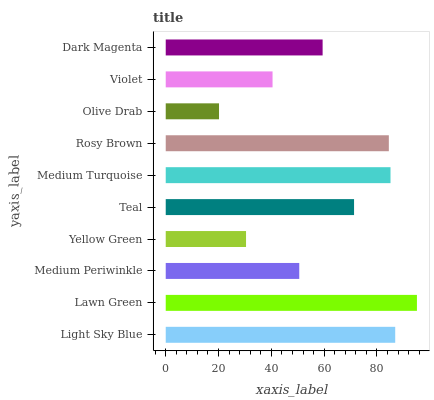Is Olive Drab the minimum?
Answer yes or no. Yes. Is Lawn Green the maximum?
Answer yes or no. Yes. Is Medium Periwinkle the minimum?
Answer yes or no. No. Is Medium Periwinkle the maximum?
Answer yes or no. No. Is Lawn Green greater than Medium Periwinkle?
Answer yes or no. Yes. Is Medium Periwinkle less than Lawn Green?
Answer yes or no. Yes. Is Medium Periwinkle greater than Lawn Green?
Answer yes or no. No. Is Lawn Green less than Medium Periwinkle?
Answer yes or no. No. Is Teal the high median?
Answer yes or no. Yes. Is Dark Magenta the low median?
Answer yes or no. Yes. Is Light Sky Blue the high median?
Answer yes or no. No. Is Yellow Green the low median?
Answer yes or no. No. 